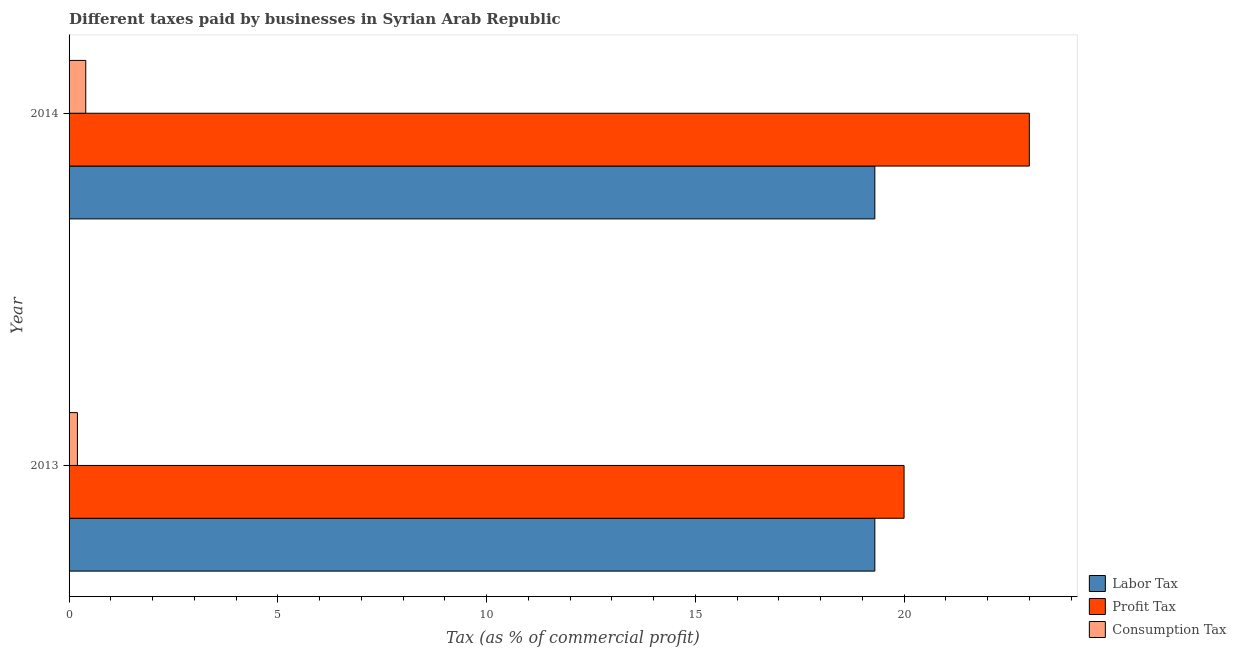How many groups of bars are there?
Your response must be concise. 2. Are the number of bars per tick equal to the number of legend labels?
Provide a succinct answer. Yes. How many bars are there on the 2nd tick from the bottom?
Your response must be concise. 3. In how many cases, is the number of bars for a given year not equal to the number of legend labels?
Provide a short and direct response. 0. What is the percentage of labor tax in 2014?
Ensure brevity in your answer.  19.3. Across all years, what is the maximum percentage of labor tax?
Your answer should be compact. 19.3. Across all years, what is the minimum percentage of profit tax?
Your answer should be very brief. 20. What is the total percentage of consumption tax in the graph?
Keep it short and to the point. 0.6. What is the difference between the percentage of profit tax in 2013 and the percentage of labor tax in 2014?
Your response must be concise. 0.7. In the year 2014, what is the difference between the percentage of profit tax and percentage of consumption tax?
Your response must be concise. 22.6. In how many years, is the percentage of consumption tax greater than 20 %?
Keep it short and to the point. 0. Is the percentage of consumption tax in 2013 less than that in 2014?
Give a very brief answer. Yes. What does the 3rd bar from the top in 2013 represents?
Offer a very short reply. Labor Tax. What does the 3rd bar from the bottom in 2014 represents?
Offer a terse response. Consumption Tax. How many bars are there?
Your answer should be compact. 6. How many years are there in the graph?
Your answer should be very brief. 2. Does the graph contain grids?
Offer a very short reply. No. Where does the legend appear in the graph?
Give a very brief answer. Bottom right. How many legend labels are there?
Offer a terse response. 3. What is the title of the graph?
Provide a short and direct response. Different taxes paid by businesses in Syrian Arab Republic. Does "Machinery" appear as one of the legend labels in the graph?
Your answer should be compact. No. What is the label or title of the X-axis?
Ensure brevity in your answer.  Tax (as % of commercial profit). What is the Tax (as % of commercial profit) in Labor Tax in 2013?
Give a very brief answer. 19.3. What is the Tax (as % of commercial profit) in Profit Tax in 2013?
Provide a succinct answer. 20. What is the Tax (as % of commercial profit) of Labor Tax in 2014?
Offer a very short reply. 19.3. What is the Tax (as % of commercial profit) in Profit Tax in 2014?
Your answer should be very brief. 23. What is the Tax (as % of commercial profit) of Consumption Tax in 2014?
Provide a succinct answer. 0.4. Across all years, what is the maximum Tax (as % of commercial profit) of Labor Tax?
Keep it short and to the point. 19.3. Across all years, what is the maximum Tax (as % of commercial profit) of Consumption Tax?
Provide a short and direct response. 0.4. Across all years, what is the minimum Tax (as % of commercial profit) of Labor Tax?
Ensure brevity in your answer.  19.3. Across all years, what is the minimum Tax (as % of commercial profit) in Consumption Tax?
Your answer should be very brief. 0.2. What is the total Tax (as % of commercial profit) of Labor Tax in the graph?
Offer a terse response. 38.6. What is the total Tax (as % of commercial profit) of Consumption Tax in the graph?
Give a very brief answer. 0.6. What is the difference between the Tax (as % of commercial profit) of Labor Tax in 2013 and the Tax (as % of commercial profit) of Consumption Tax in 2014?
Provide a succinct answer. 18.9. What is the difference between the Tax (as % of commercial profit) of Profit Tax in 2013 and the Tax (as % of commercial profit) of Consumption Tax in 2014?
Your answer should be compact. 19.6. What is the average Tax (as % of commercial profit) in Labor Tax per year?
Provide a succinct answer. 19.3. What is the average Tax (as % of commercial profit) in Profit Tax per year?
Offer a terse response. 21.5. What is the average Tax (as % of commercial profit) of Consumption Tax per year?
Ensure brevity in your answer.  0.3. In the year 2013, what is the difference between the Tax (as % of commercial profit) of Labor Tax and Tax (as % of commercial profit) of Consumption Tax?
Your answer should be compact. 19.1. In the year 2013, what is the difference between the Tax (as % of commercial profit) in Profit Tax and Tax (as % of commercial profit) in Consumption Tax?
Your answer should be compact. 19.8. In the year 2014, what is the difference between the Tax (as % of commercial profit) in Profit Tax and Tax (as % of commercial profit) in Consumption Tax?
Offer a very short reply. 22.6. What is the ratio of the Tax (as % of commercial profit) of Profit Tax in 2013 to that in 2014?
Make the answer very short. 0.87. What is the difference between the highest and the lowest Tax (as % of commercial profit) in Labor Tax?
Offer a terse response. 0. What is the difference between the highest and the lowest Tax (as % of commercial profit) in Profit Tax?
Provide a short and direct response. 3. 